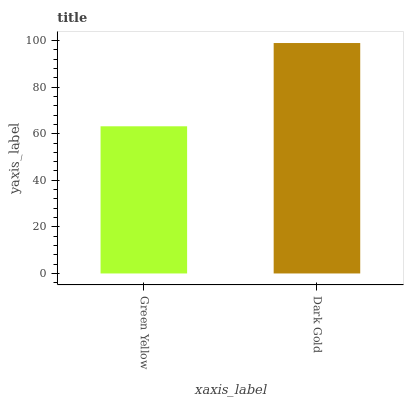Is Green Yellow the minimum?
Answer yes or no. Yes. Is Dark Gold the maximum?
Answer yes or no. Yes. Is Dark Gold the minimum?
Answer yes or no. No. Is Dark Gold greater than Green Yellow?
Answer yes or no. Yes. Is Green Yellow less than Dark Gold?
Answer yes or no. Yes. Is Green Yellow greater than Dark Gold?
Answer yes or no. No. Is Dark Gold less than Green Yellow?
Answer yes or no. No. Is Dark Gold the high median?
Answer yes or no. Yes. Is Green Yellow the low median?
Answer yes or no. Yes. Is Green Yellow the high median?
Answer yes or no. No. Is Dark Gold the low median?
Answer yes or no. No. 